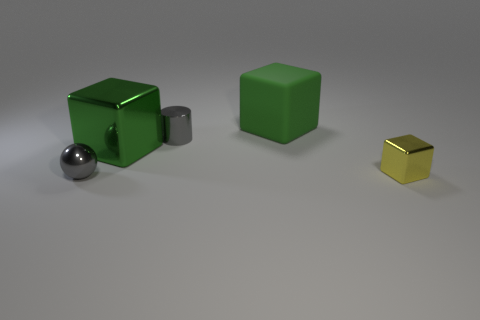Subtract all shiny blocks. How many blocks are left? 1 Subtract all red spheres. How many green cubes are left? 2 Add 4 gray metal objects. How many objects exist? 9 Subtract all blocks. How many objects are left? 2 Subtract all blue blocks. Subtract all brown cylinders. How many blocks are left? 3 Subtract 0 cyan balls. How many objects are left? 5 Subtract all small gray metallic things. Subtract all small metal cylinders. How many objects are left? 2 Add 4 green blocks. How many green blocks are left? 6 Add 4 large shiny objects. How many large shiny objects exist? 5 